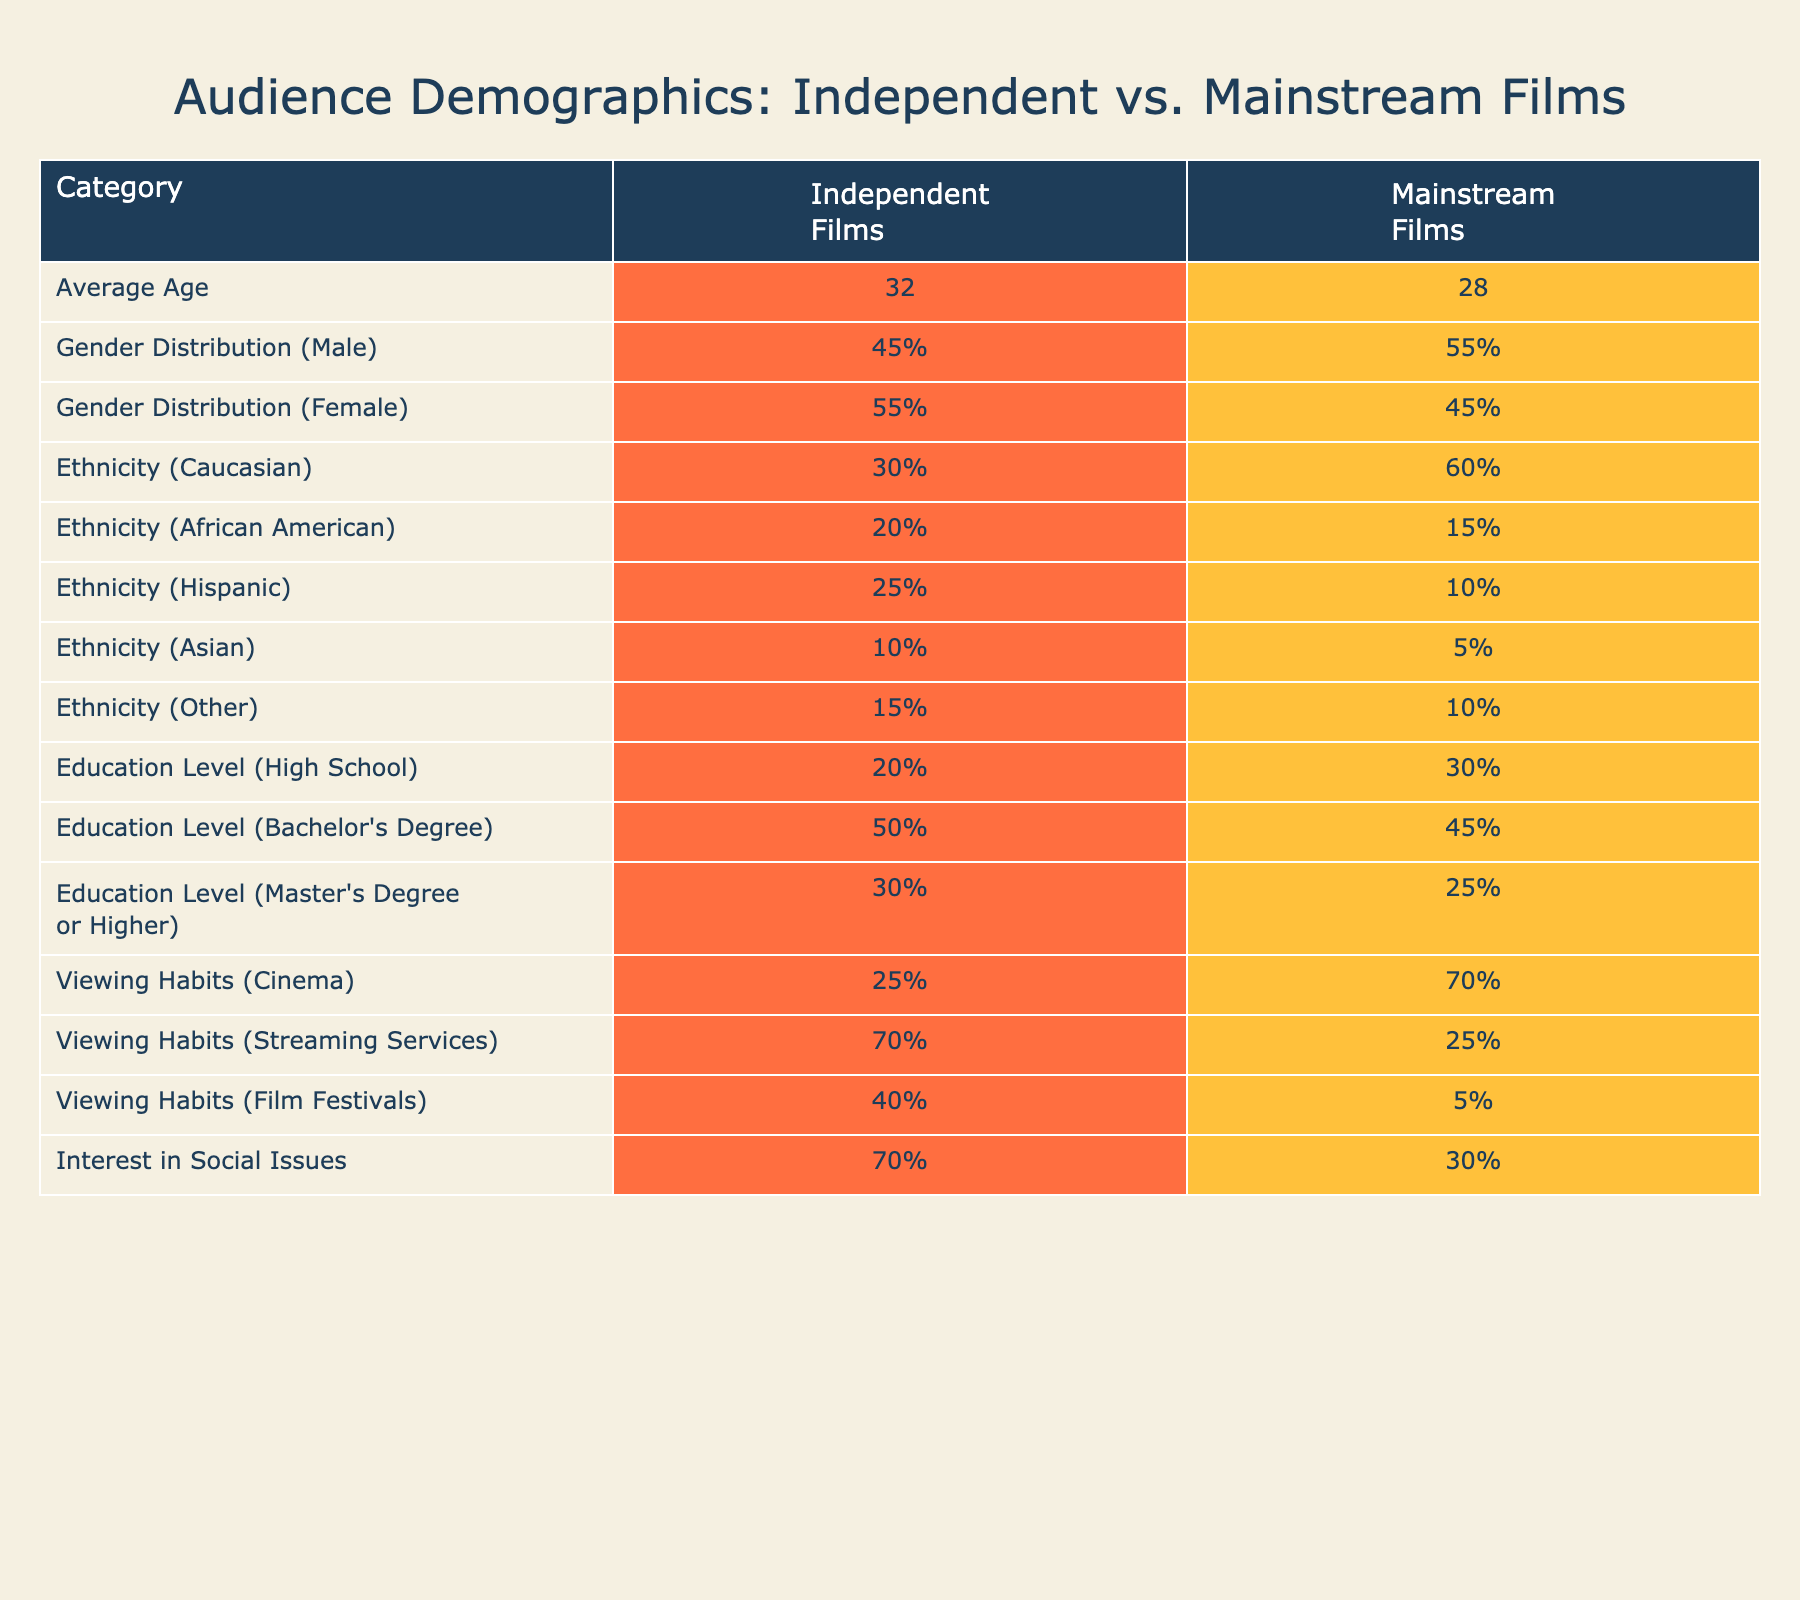What is the average age of the audience for independent films? The table indicates that the average age of the audience for independent films is listed as 32.
Answer: 32 What percentage of the audience for mainstream films identifies as female? Referring to the gender distribution in the table, 45% of the audience for mainstream films identifies as female.
Answer: 45% Is the percentage of African American viewers higher for independent films compared to mainstream films? The table shows that 20% of independent film viewers are African American, while only 15% of mainstream film viewers are. Since 20% is greater than 15%, the statement is true.
Answer: Yes What is the combined percentage of the audience for independent films that have a Master’s degree or higher compared to those with a Bachelor's degree? From the table, 30% of independent film viewers have a Master’s degree or higher, and 50% have a Bachelor’s degree. Adding these percentages gives 30 + 50 = 80%.
Answer: 80% How much more likely are independent film viewers to watch films at festivals compared to mainstream film viewers? The table indicates that 40% of independent film viewers go to film festivals, while only 5% of mainstream viewers do. The difference is 40% - 5% = 35%. Therefore, independent film viewers are 35% more likely to watch at festivals.
Answer: 35% Are more mainstream film viewers likely to prefer cinema as a viewing habit than independent film viewers? From the table, 70% of mainstream film viewers prefer cinema, while only 25% of independent film viewers do. Since 70% is greater than 25%, the statement is true.
Answer: Yes What percentage of viewers interested in social issues prefer independent films? According to the table, 70% of independent film viewers express an interest in social issues.
Answer: 70% If we combine the percentages of Hispanic and Asian audiences for independent films, what is the total? The table shows that 25% of independent film viewers are Hispanic and 10% are Asian. Adding these gives 25 + 10 = 35%.
Answer: 35% What is the difference in the percentage of viewers identifying as Caucasian between independent and mainstream films? The percentage of Caucasian viewers for independent films is 30% while for mainstream films it is 60%. The difference is 60% - 30% = 30%.
Answer: 30% 